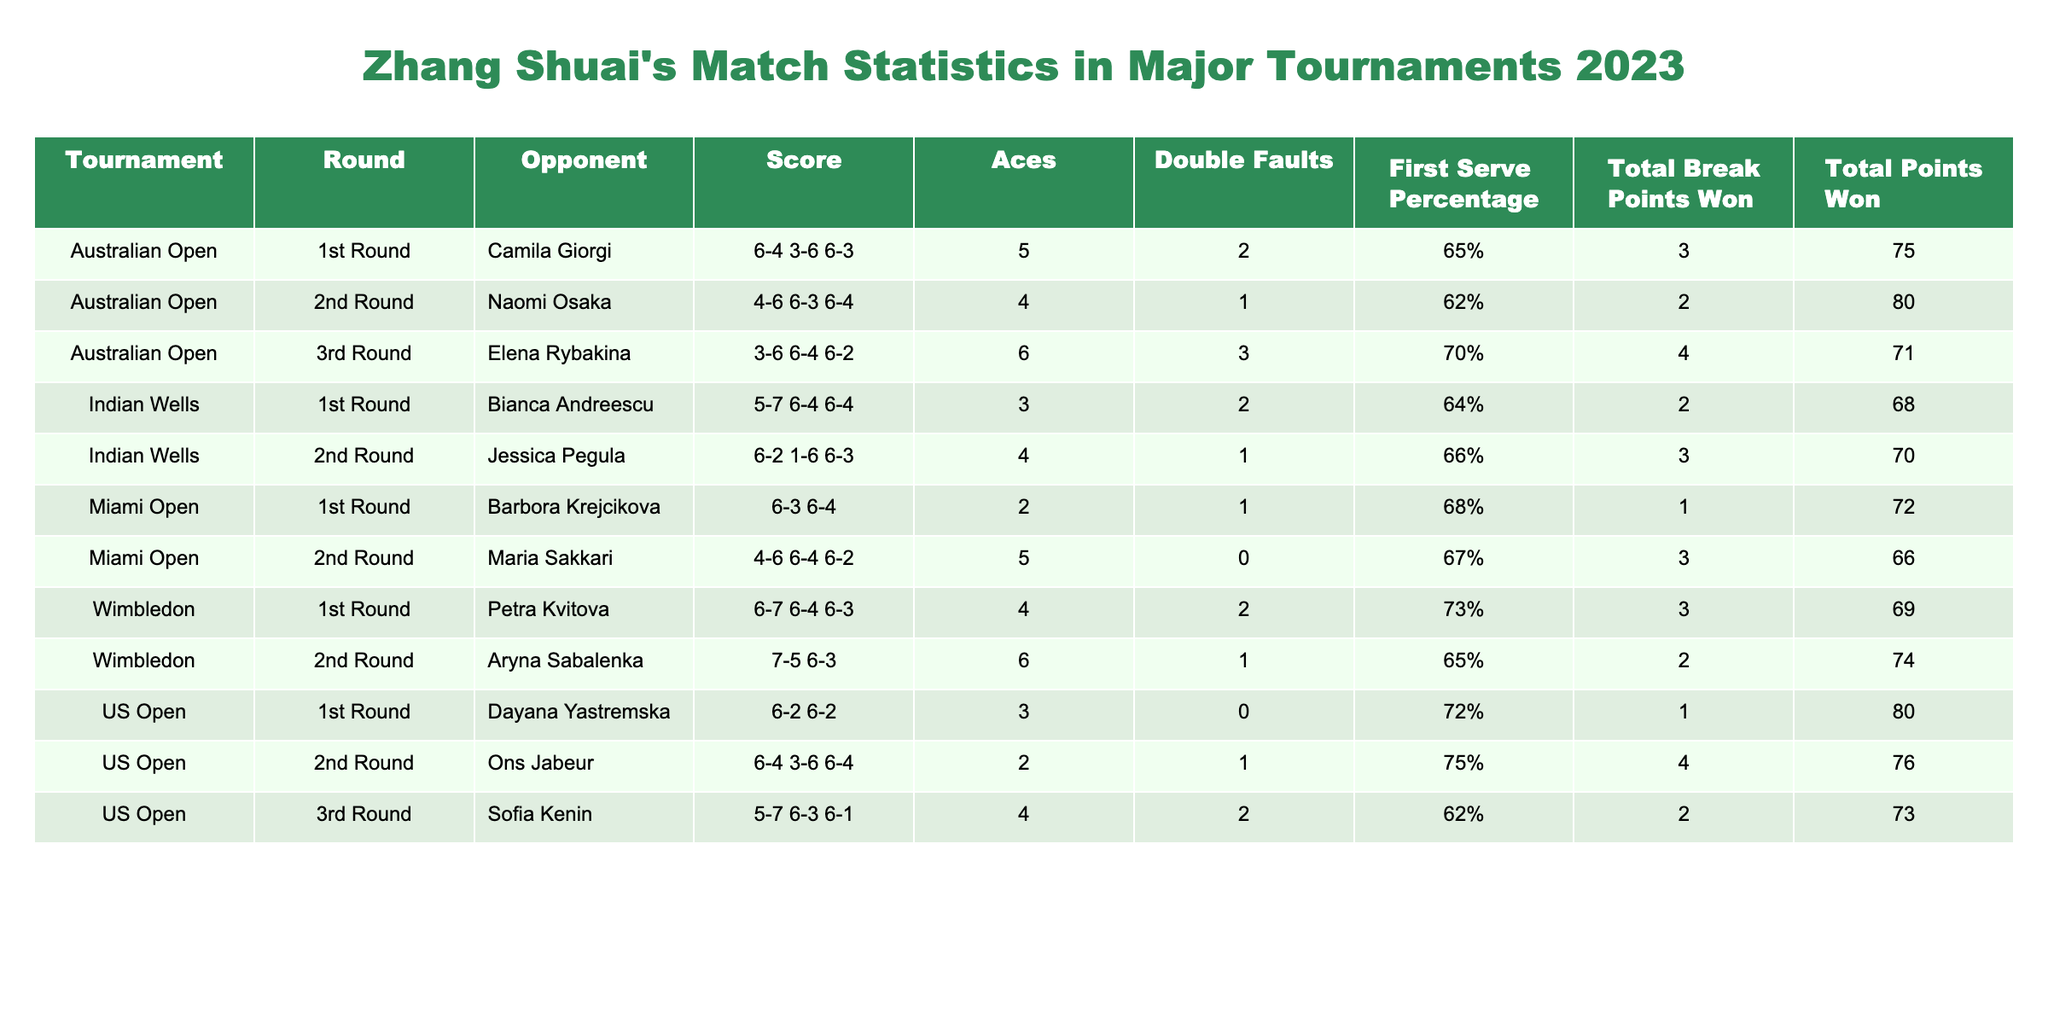What was Zhang Shuai's score against Naomi Osaka in the Australian Open? In the table, the match against Naomi Osaka in the Australian Open is listed with the score 4-6 6-3 6-4.
Answer: 4-6 6-3 6-4 How many total break points did Zhang Shuai win against Elena Rybakina? According to the table, the total break points won against Elena Rybakina is listed as 4.
Answer: 4 Did Zhang Shuai win all her matches in the US Open? In the table, the results show that Zhang Shuai won two matches and lost one in the US Open, specifically losing to Sofia Kenin.
Answer: No What is the average number of aces Zhang Shuai hit across all tournaments listed? Summing the aces: 5 + 4 + 6 + 3 + 4 + 2 + 4 + 3 + 2 + 4 = 43. There are 10 matches, so the average is 43 / 10 = 4.3.
Answer: 4.3 Which tournament did Zhang Shuai achieve the highest number of total points won? Looking at the total points won in each match, the highest is 80, achieved in the US Open 1st Round against Dayana Yastremska.
Answer: US Open What was Zhang Shuai's first serve percentage in the match against Aryna Sabalenka? In the table, the first serve percentage against Aryna Sabalenka is listed as 65%.
Answer: 65% How many double faults did Zhang Shuai have in the Miami Open compared to the Australian Open? In the Miami Open, Zhang Shuai had 1 double fault in the 1st Round and 0 in the 2nd Round, totaling 1. In the Australian Open, she had 2 double faults in the 1st Round, 1 in the 2nd Round, and 3 in the 3rd Round, totaling 6.
Answer: 1 (Miami Open), 6 (Australian Open) Was Zhang Shuai's first serve percentage lower in the Indian Wells tournaments than in the Australian Open tournaments? Analyzing the data, her first serve percentages were 65%, 62%, and 70% in Australian Open for the three rounds, and 64% and 66% in Indian Wells, making the average for Australian Open 65.67% and for Indian Wells 65%. Hence, it is not lower.
Answer: No What is the difference in total points won between the match against Bianca Andreescu and that against Maria Sakkari? The total points won against Bianca Andreescu is 68, and against Maria Sakkari is 66. The difference is 68 - 66 = 2.
Answer: 2 Which round did Zhang Shuai have the most double faults in? By examining the data, the 3rd Round of the Australian Open shows the highest with 3 double faults against Elena Rybakina.
Answer: 3rd Round (Australian Open) 